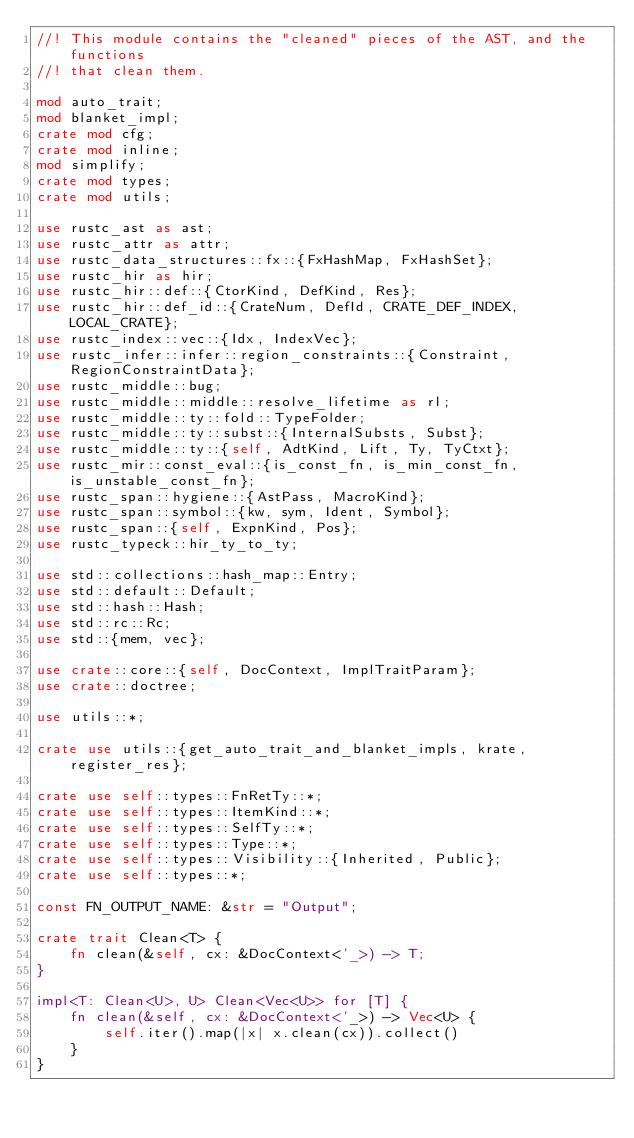<code> <loc_0><loc_0><loc_500><loc_500><_Rust_>//! This module contains the "cleaned" pieces of the AST, and the functions
//! that clean them.

mod auto_trait;
mod blanket_impl;
crate mod cfg;
crate mod inline;
mod simplify;
crate mod types;
crate mod utils;

use rustc_ast as ast;
use rustc_attr as attr;
use rustc_data_structures::fx::{FxHashMap, FxHashSet};
use rustc_hir as hir;
use rustc_hir::def::{CtorKind, DefKind, Res};
use rustc_hir::def_id::{CrateNum, DefId, CRATE_DEF_INDEX, LOCAL_CRATE};
use rustc_index::vec::{Idx, IndexVec};
use rustc_infer::infer::region_constraints::{Constraint, RegionConstraintData};
use rustc_middle::bug;
use rustc_middle::middle::resolve_lifetime as rl;
use rustc_middle::ty::fold::TypeFolder;
use rustc_middle::ty::subst::{InternalSubsts, Subst};
use rustc_middle::ty::{self, AdtKind, Lift, Ty, TyCtxt};
use rustc_mir::const_eval::{is_const_fn, is_min_const_fn, is_unstable_const_fn};
use rustc_span::hygiene::{AstPass, MacroKind};
use rustc_span::symbol::{kw, sym, Ident, Symbol};
use rustc_span::{self, ExpnKind, Pos};
use rustc_typeck::hir_ty_to_ty;

use std::collections::hash_map::Entry;
use std::default::Default;
use std::hash::Hash;
use std::rc::Rc;
use std::{mem, vec};

use crate::core::{self, DocContext, ImplTraitParam};
use crate::doctree;

use utils::*;

crate use utils::{get_auto_trait_and_blanket_impls, krate, register_res};

crate use self::types::FnRetTy::*;
crate use self::types::ItemKind::*;
crate use self::types::SelfTy::*;
crate use self::types::Type::*;
crate use self::types::Visibility::{Inherited, Public};
crate use self::types::*;

const FN_OUTPUT_NAME: &str = "Output";

crate trait Clean<T> {
    fn clean(&self, cx: &DocContext<'_>) -> T;
}

impl<T: Clean<U>, U> Clean<Vec<U>> for [T] {
    fn clean(&self, cx: &DocContext<'_>) -> Vec<U> {
        self.iter().map(|x| x.clean(cx)).collect()
    }
}
</code> 